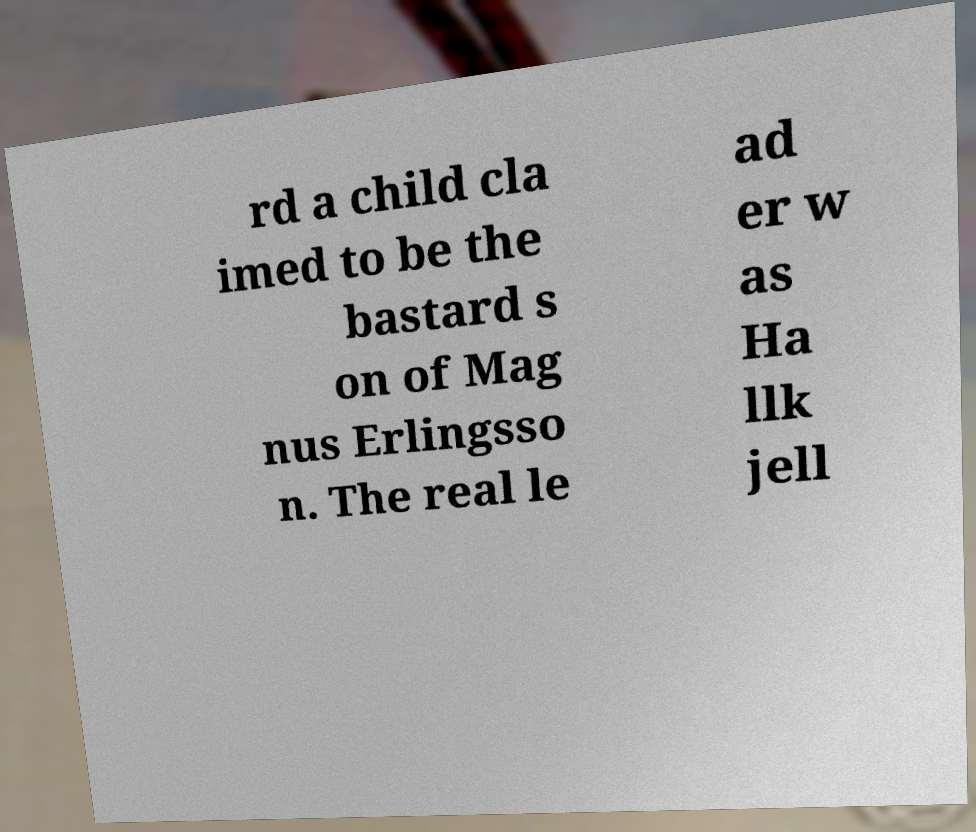Could you extract and type out the text from this image? rd a child cla imed to be the bastard s on of Mag nus Erlingsso n. The real le ad er w as Ha llk jell 